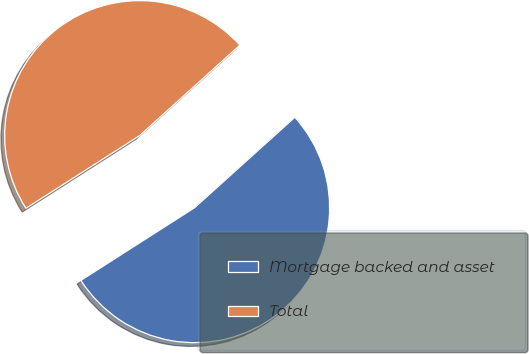<chart> <loc_0><loc_0><loc_500><loc_500><pie_chart><fcel>Mortgage backed and asset<fcel>Total<nl><fcel>52.63%<fcel>47.37%<nl></chart> 